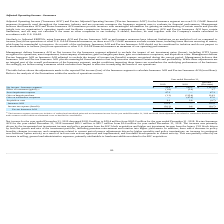According to Hc2 Holdings's financial document, What was the increase / (decrease) in the net income - insurance segment from 2018 to 2019? According to the financial document, $(105.8) (in millions). The relevant text states: "Net income - Insurance segment $ 59.4 $ 165.2 $ (105.8)..." Also, What was the increase / (decrease) in the effect of investment gains from 2018 to 2019? According to the financial document, 3.7 (in millions). The relevant text states: "Effect of investment (gains) (1) (1.9) (5.6) 3.7..." Also, What was the increase / (decrease) in the asset impairment expense from 2018 to 2019? According to the financial document, 47.3 (in millions). The relevant text states: "Asset impairment expense 47.3 — 47.3..." Also, can you calculate: What is the percentage change in the net income - insurance segment from 2018 to 2019? To answer this question, I need to perform calculations using the financial data. The calculation is: 59.4 / 165.2 - 1, which equals -64.04 (percentage). This is based on the information: "Net income - Insurance segment $ 59.4 $ 165.2 $ (105.8) Net income - Insurance segment $ 59.4 $ 165.2 $ (105.8)..." The key data points involved are: 165.2, 59.4. Also, can you calculate: What is the average effect of investment gains for 2018 and 2019? To answer this question, I need to perform calculations using the financial data. The calculation is: -(1.9 + 5.6) / 2, which equals -3.75 (in millions). This is based on the information: "Effect of investment (gains) (1) (1.9) (5.6) 3.7 Effect of investment (gains) (1) (1.9) (5.6) 3.7..." The key data points involved are: 1.9, 5.6. Also, can you calculate: What is the percentage change in the gain on bargain purchase from 2018 to 2019? To answer this question, I need to perform calculations using the financial data. The calculation is: -1.1 / -115.4 - 1, which equals -99.05 (percentage). This is based on the information: "Gain on bargain purchase (1.1) (115.4) 114.3 Gain on bargain purchase (1.1) (115.4) 114.3..." The key data points involved are: 1.1, 115.4. 